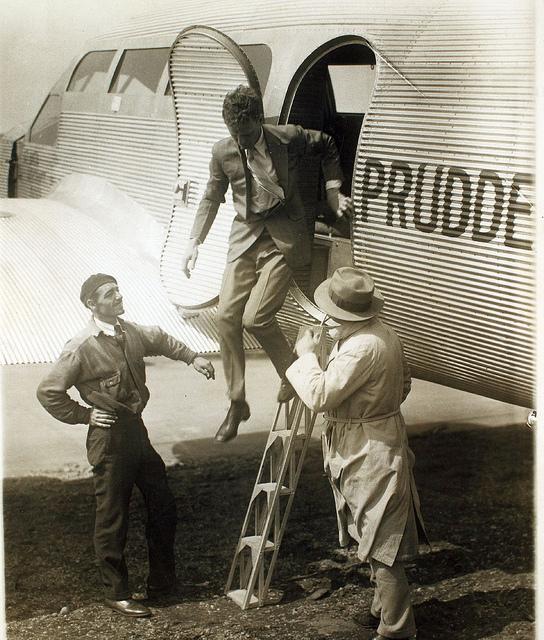What is written on the plane?
Quick response, please. Prude. How many men are wearing hats?
Write a very short answer. 1. How is the man getting out the plane?
Concise answer only. Ladder. 